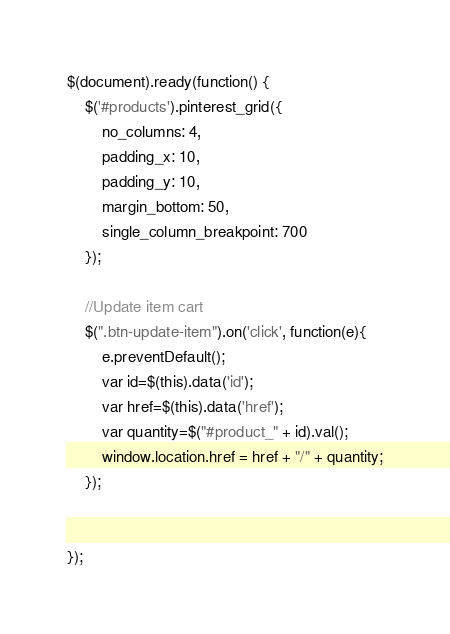<code> <loc_0><loc_0><loc_500><loc_500><_JavaScript_>$(document).ready(function() {
	$('#products').pinterest_grid({
		no_columns: 4,
		padding_x: 10,
		padding_y: 10,
		margin_bottom: 50,
		single_column_breakpoint: 700
	});

	//Update item cart
	$(".btn-update-item").on('click', function(e){
		e.preventDefault();
		var id=$(this).data('id');
		var href=$(this).data('href');
		var quantity=$("#product_" + id).val();
		window.location.href = href + "/" + quantity;
	});


});
</code> 